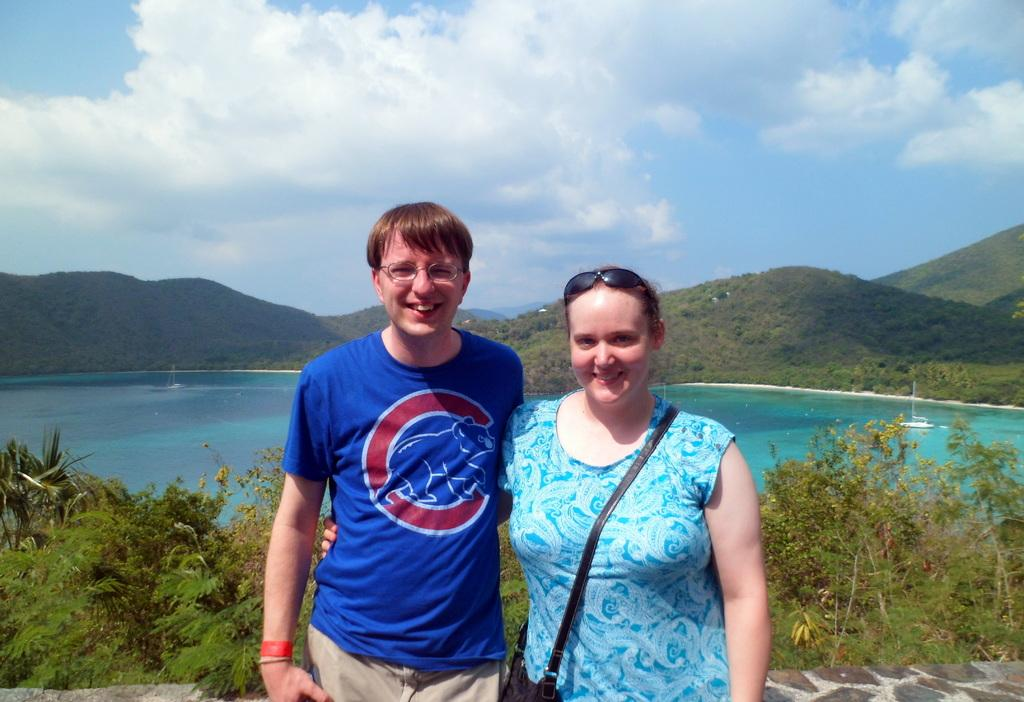What can be seen in the image in terms of human presence? There are people standing in the image. Can you describe the woman's accessory in the image? A woman is wearing a handbag in the image. What type of natural environment is visible in the image? There are trees, water, hills, and a blue and cloudy sky visible in the image. What is present in the water in the image? There are boats in the water in the image. What type of bun is being used to hold the trees together in the image? There is no bun present in the image; it features people, a woman with a handbag, trees, water, hills, boats, and a blue and cloudy sky. How many sticks are being used to support the hills in the image? There are no sticks visible in the image; the hills are part of the natural landscape. 